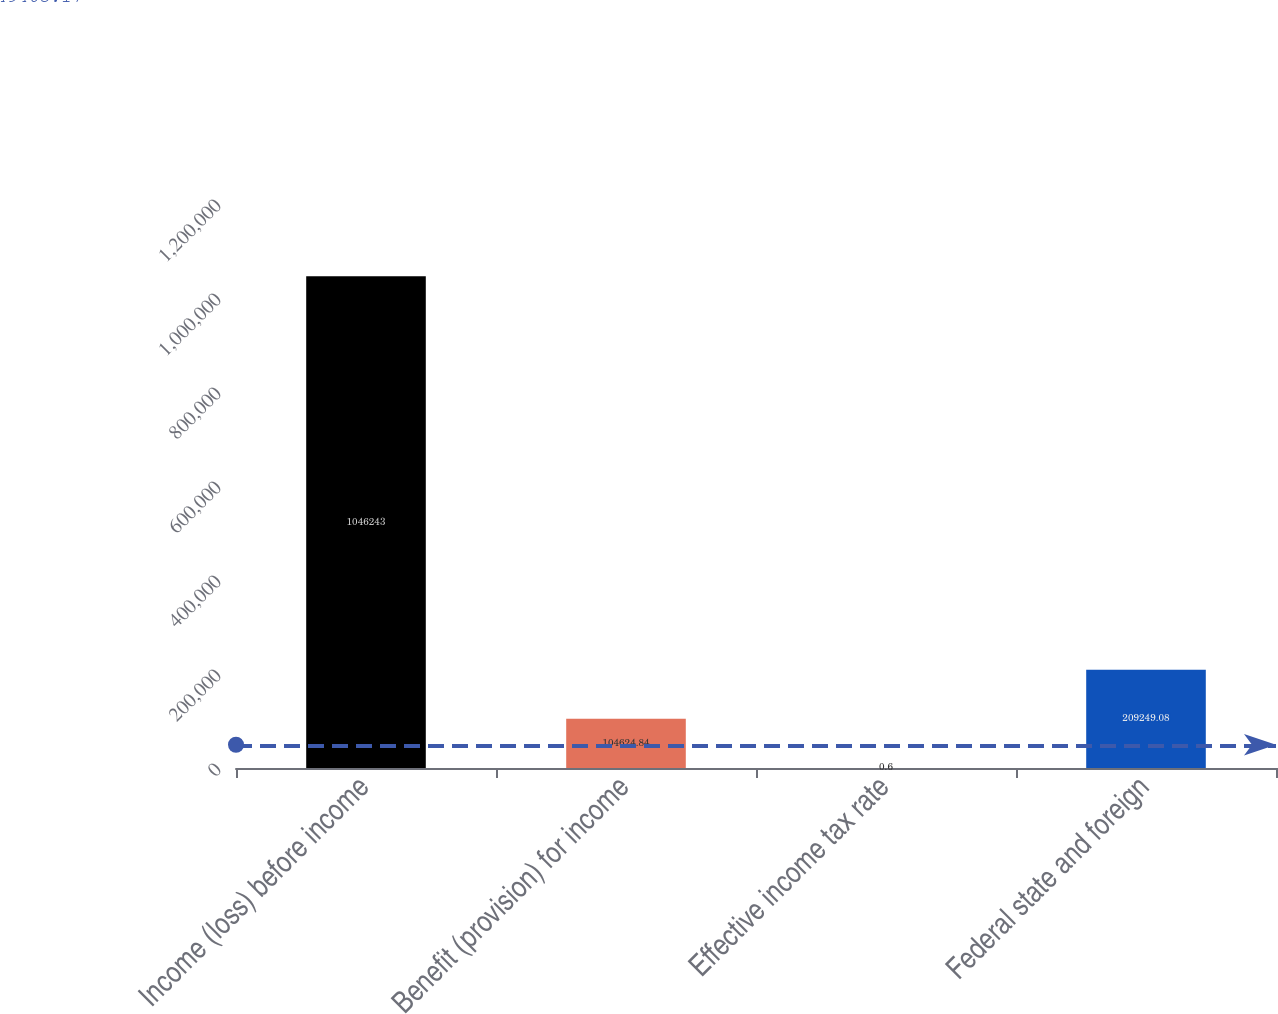Convert chart to OTSL. <chart><loc_0><loc_0><loc_500><loc_500><bar_chart><fcel>Income (loss) before income<fcel>Benefit (provision) for income<fcel>Effective income tax rate<fcel>Federal state and foreign<nl><fcel>1.04624e+06<fcel>104625<fcel>0.6<fcel>209249<nl></chart> 